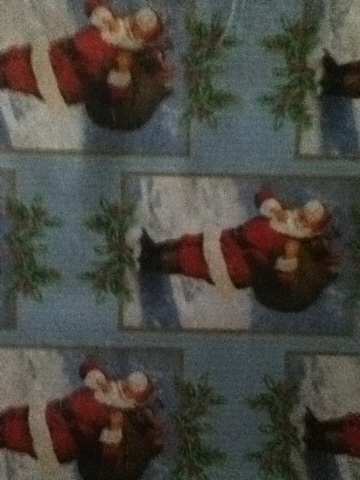Can you tell me what type of wrapping paper this is: if it's a regular or if it's a Christmas wrap? Thank you. The wrapping paper in the image is clearly a Christmas wrap. It features a festive design with images of Santa Claus, which is a common theme associated with Christmas. 